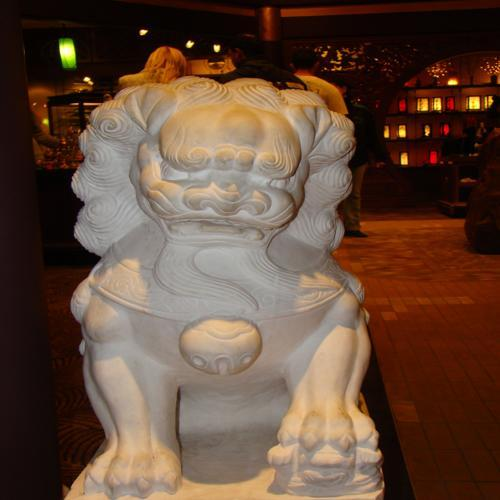What is the overall sharpness of the image?
A. Excellent
B. Acceptable
C. Blurry The overall sharpness of the image is Acceptable (B). While the subject—the statue of what appears to be a guardian lion—is in focus, some details could be sharper to enhance clarity. Additionally, the shot is taken with adequate lighting, which helps in maintaining the definition of the image. 